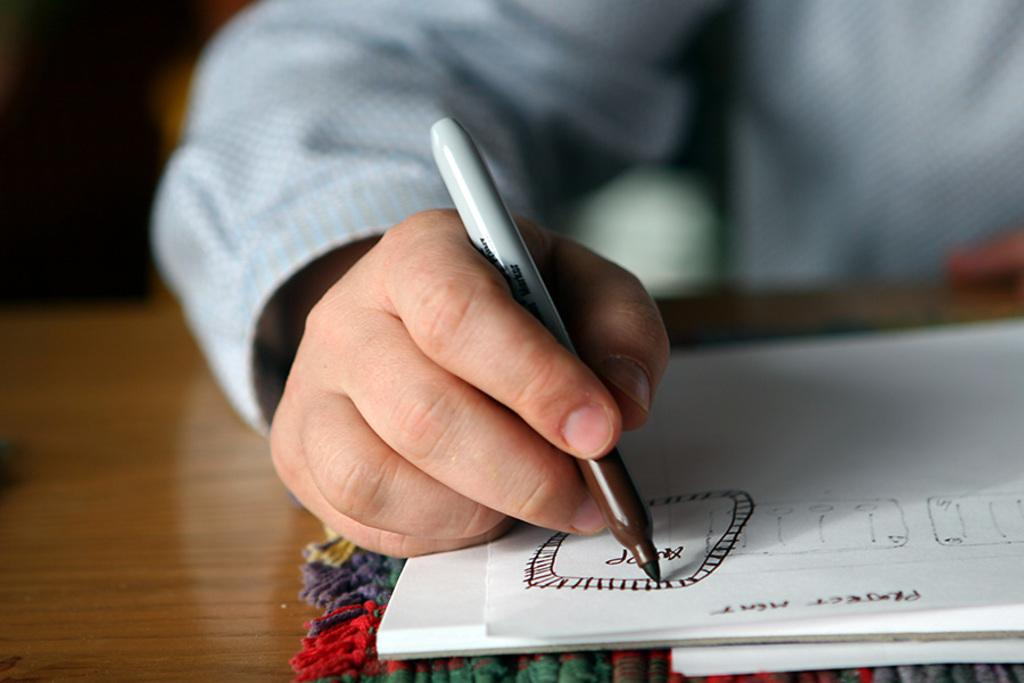Who is present in the image? There is a person in the image. What is the person holding in the image? The person is holding a pen. What object can be seen on the table in the image? There is a book on a table in the image. What is the color of the table in the image? The table is brown. What type of fabric is present in the image? There is a multicolored cloth in the image. What type of hat is the person wearing in the image? There is no hat present in the image. 